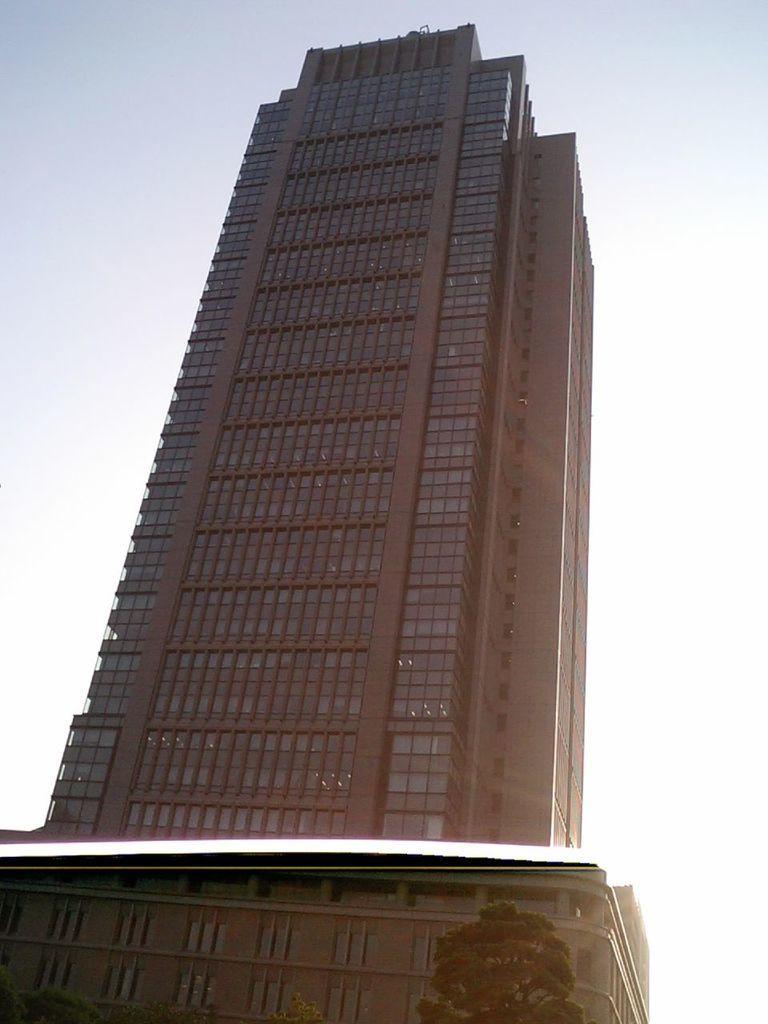Can you describe this image briefly? In this image in front there are trees, buildings. In the background of the image there is sky. 